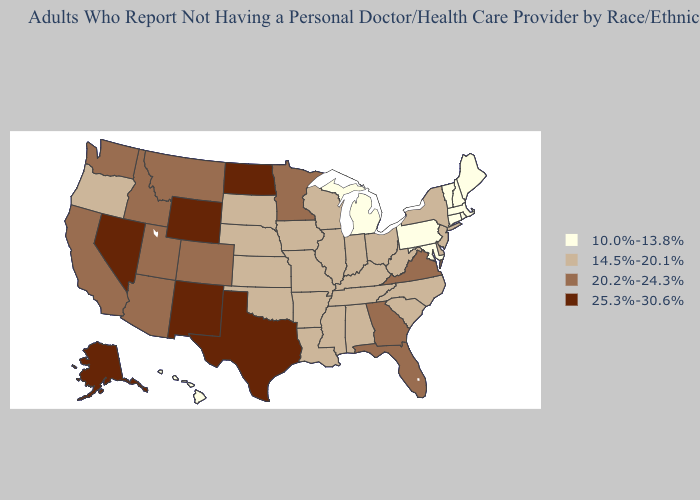Does Minnesota have a higher value than Virginia?
Give a very brief answer. No. Name the states that have a value in the range 10.0%-13.8%?
Give a very brief answer. Connecticut, Hawaii, Maine, Maryland, Massachusetts, Michigan, New Hampshire, Pennsylvania, Rhode Island, Vermont. Name the states that have a value in the range 25.3%-30.6%?
Keep it brief. Alaska, Nevada, New Mexico, North Dakota, Texas, Wyoming. What is the value of Michigan?
Concise answer only. 10.0%-13.8%. What is the lowest value in the USA?
Give a very brief answer. 10.0%-13.8%. Does Nevada have the highest value in the USA?
Give a very brief answer. Yes. Which states have the lowest value in the MidWest?
Answer briefly. Michigan. How many symbols are there in the legend?
Give a very brief answer. 4. Name the states that have a value in the range 10.0%-13.8%?
Concise answer only. Connecticut, Hawaii, Maine, Maryland, Massachusetts, Michigan, New Hampshire, Pennsylvania, Rhode Island, Vermont. Does the first symbol in the legend represent the smallest category?
Concise answer only. Yes. How many symbols are there in the legend?
Answer briefly. 4. Is the legend a continuous bar?
Concise answer only. No. Does New York have a higher value than Michigan?
Quick response, please. Yes. Which states hav the highest value in the South?
Give a very brief answer. Texas. 